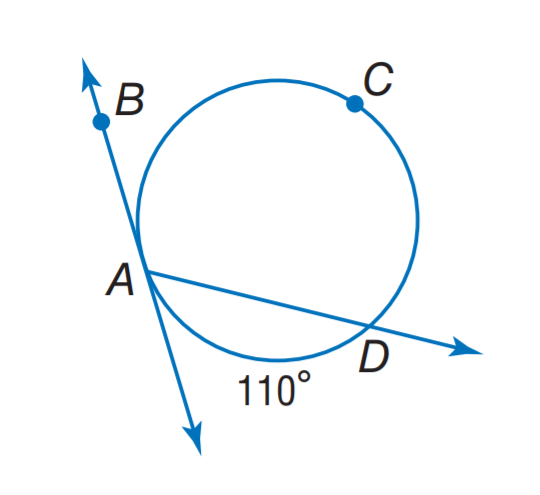Question: Find m \angle D A B.
Choices:
A. 55
B. 110
C. 125
D. 135
Answer with the letter. Answer: C 